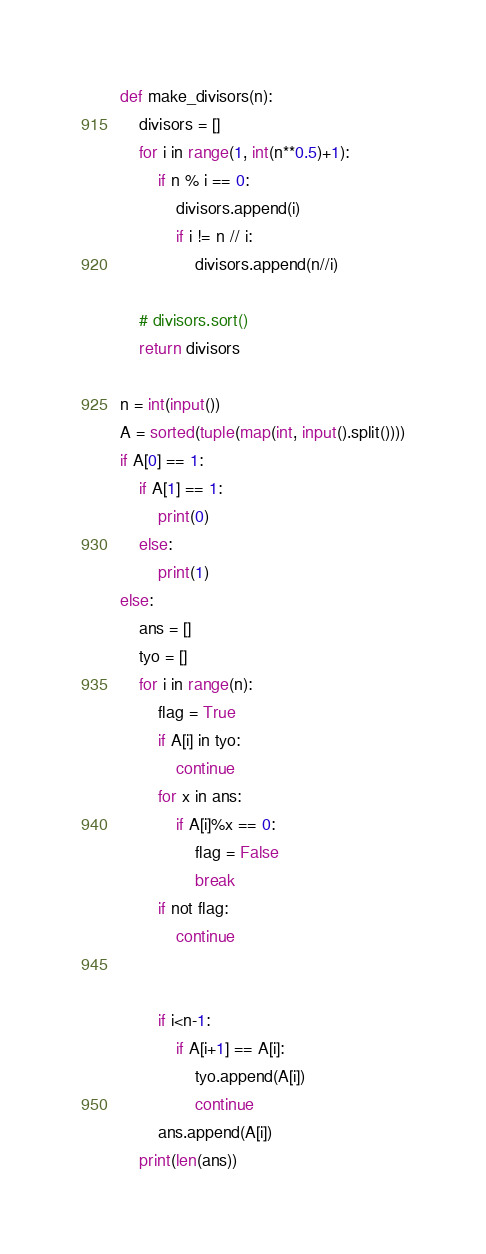Convert code to text. <code><loc_0><loc_0><loc_500><loc_500><_Python_>def make_divisors(n):
    divisors = []
    for i in range(1, int(n**0.5)+1):
        if n % i == 0:
            divisors.append(i)
            if i != n // i:
                divisors.append(n//i)

    # divisors.sort()
    return divisors

n = int(input())
A = sorted(tuple(map(int, input().split())))
if A[0] == 1:
    if A[1] == 1:
        print(0)
    else:
        print(1)
else:
    ans = []
    tyo = []
    for i in range(n):
        flag = True
        if A[i] in tyo:
            continue
        for x in ans:
            if A[i]%x == 0:
                flag = False
                break
        if not flag:
            continue


        if i<n-1:
            if A[i+1] == A[i]:
                tyo.append(A[i])
                continue
        ans.append(A[i])
    print(len(ans))</code> 